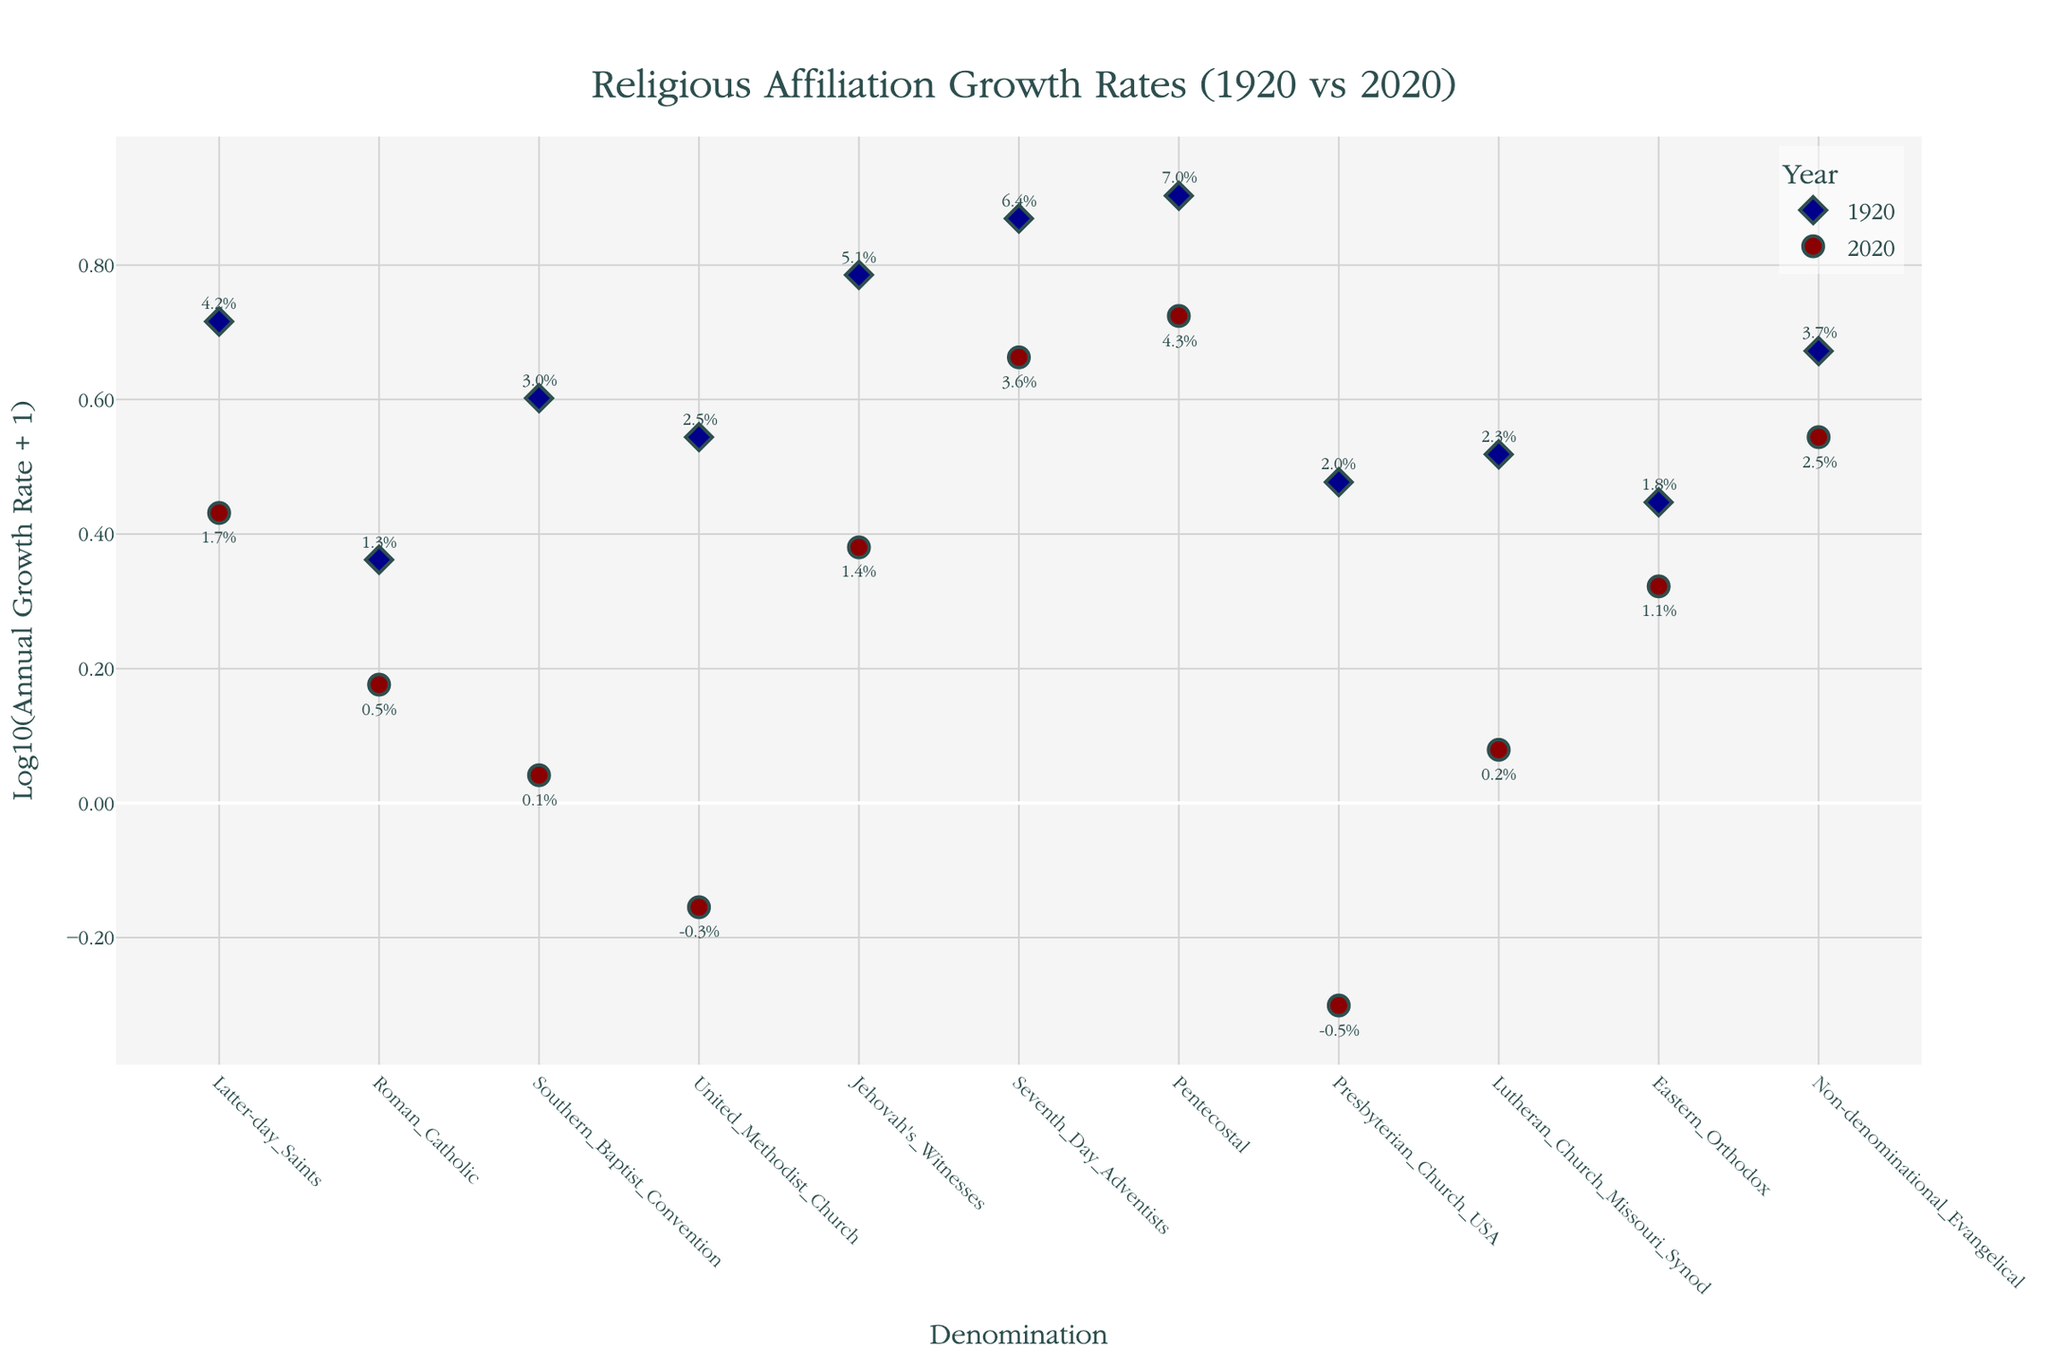What is the title of the figure? The title is located at the top of the figure and provides a quick insight into what the plot is depicting.
Answer: Religious Affiliation Growth Rates (1920 vs 2020) Which denomination had the highest growth rate in 1920? The 1920 data points use diamond markers colored in dark blue. The highest y-value among these is the highest growth rate.
Answer: Pentecostal How many denominations showed a negative growth rate in 2020? The 2020 data points use circle markers colored in dark red. Count how many of these points have y-values below 0 (the log scale transformation won't show negative values directly). Check the annotations.
Answer: Two (United Methodist Church and Presbyterian Church USA) Which year shows a higher overall growth rate, 1920 or 2020? Compare the general vertical positioning of the markers for each year. Higher positions in the plot (higher y-values) represent higher growth rates.
Answer: 1920 What is the growth rate of the Latter-day Saints in 2020? Locate the 2020 data point (circle marker in dark red) associated with the "Latter-day Saints" on the x-axis. Read the annotation near this marker.
Answer: 1.7% Did any denomination have a higher growth rate in 2020 than in 1920? Compare the vertical positions of the markers for each denomination between the two years. Check the annotations.
Answer: No Which denominations have similar growth rates in 2020? Identify the circle markers (2020) that are closely positioned along the y-axis.
Answer: Jehovah's Witnesses and Latter-day Saints What's the difference in the growth rate of Pentecostal from 1920 to 2020? Locate the position of the Pentecostal in both years. The growth rates are provided in the annotations. Subtract the 2020 value from the 1920 value.
Answer: 2.7% (7.0% - 4.3%) Which denomination experienced the largest decrease in growth rate from 1920 to 2020? For each denomination, subtract the 2020 growth rate from the 1920 growth rate. The largest positive difference is the largest decrease.
Answer: Southern Baptist Convention (2.9%) How many denominations grew within the 1%-2% range in 2020? For 2020, identify the denominations with markers between the log scale values corresponding to growth rates of approximately 1% to 2%.
Answer: Three (Eastern Orthodox, Latter-day Saints, Non-denominational Evangelical) 